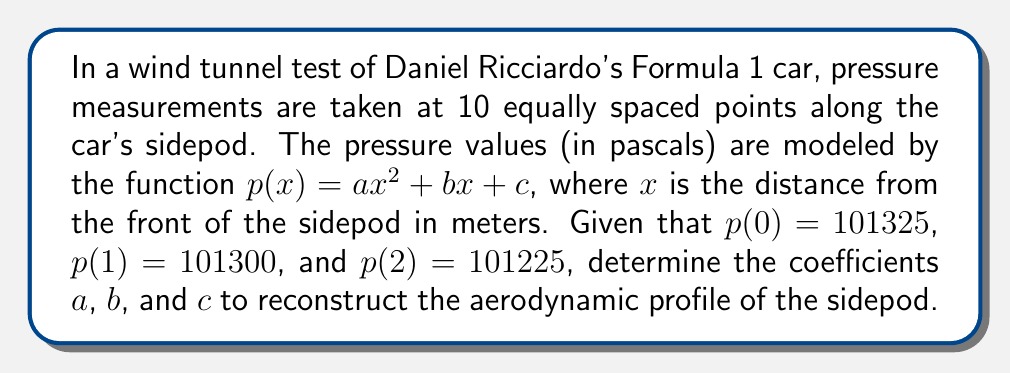Provide a solution to this math problem. Let's solve this step-by-step:

1) We have three equations based on the given information:
   $$p(0) = c = 101325$$
   $$p(1) = a + b + c = 101300$$
   $$p(2) = 4a + 2b + c = 101225$$

2) From the first equation, we know that $c = 101325$.

3) Substituting this into the second equation:
   $$a + b + 101325 = 101300$$
   $$a + b = -25$$

4) Substituting $c$ into the third equation:
   $$4a + 2b + 101325 = 101225$$
   $$4a + 2b = -100$$

5) Now we have a system of two equations:
   $$a + b = -25$$
   $$4a + 2b = -100$$

6) Multiply the first equation by 2:
   $$2a + 2b = -50$$

7) Subtract this from the second equation:
   $$2a = -50$$
   $$a = -25$$

8) Substitute this back into $a + b = -25$:
   $$-25 + b = -25$$
   $$b = 0$$

9) We now have all three coefficients:
   $$a = -25$$
   $$b = 0$$
   $$c = 101325$$

Therefore, the pressure function for the sidepod's aerodynamic profile is:
$$p(x) = -25x^2 + 101325$$
Answer: $a = -25$, $b = 0$, $c = 101325$ 